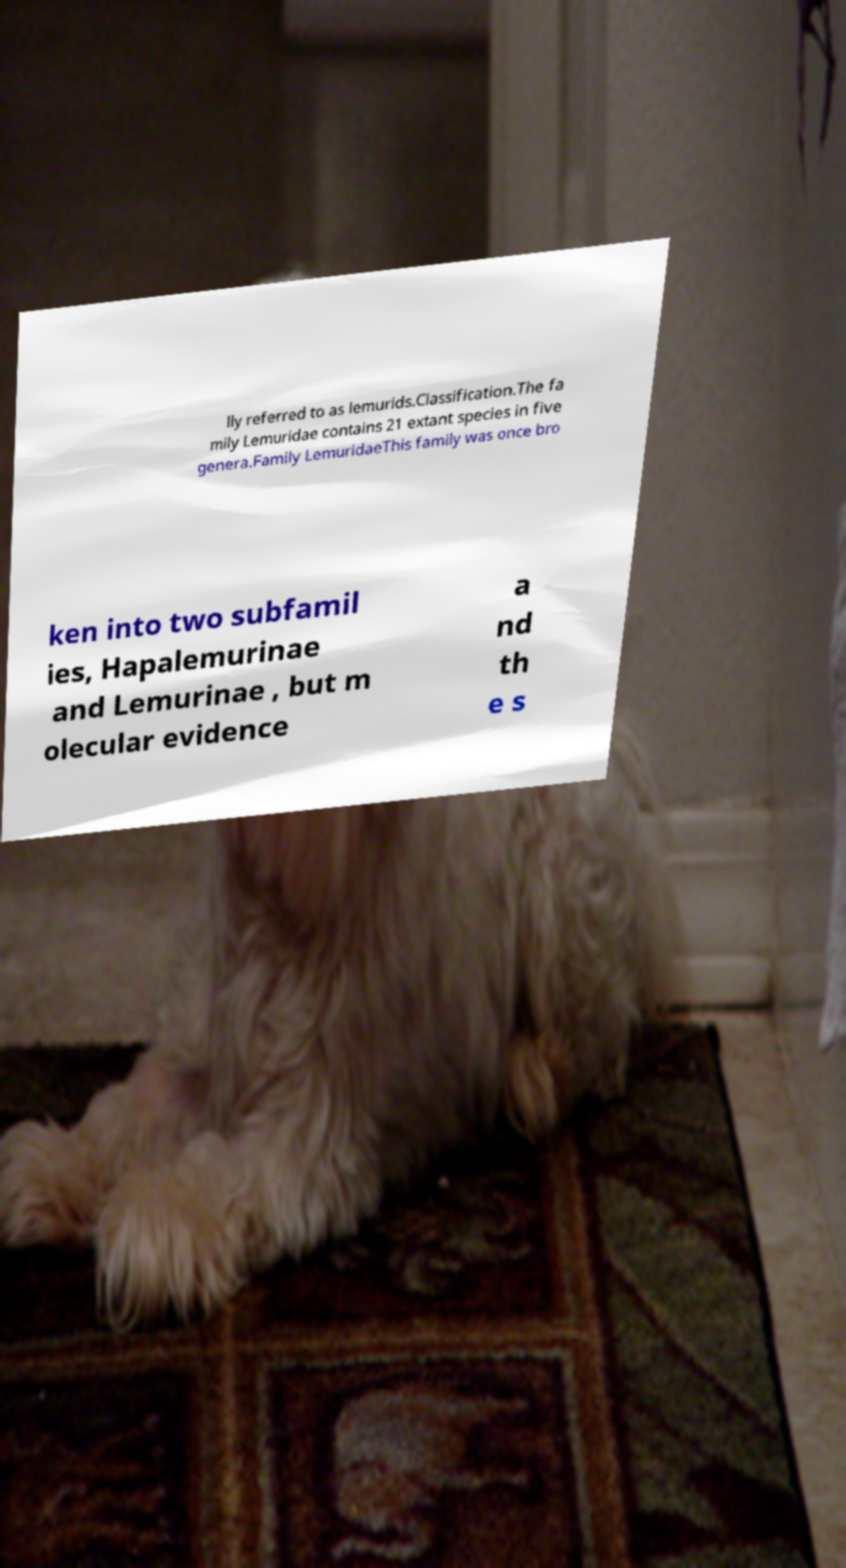For documentation purposes, I need the text within this image transcribed. Could you provide that? lly referred to as lemurids.Classification.The fa mily Lemuridae contains 21 extant species in five genera.Family LemuridaeThis family was once bro ken into two subfamil ies, Hapalemurinae and Lemurinae , but m olecular evidence a nd th e s 